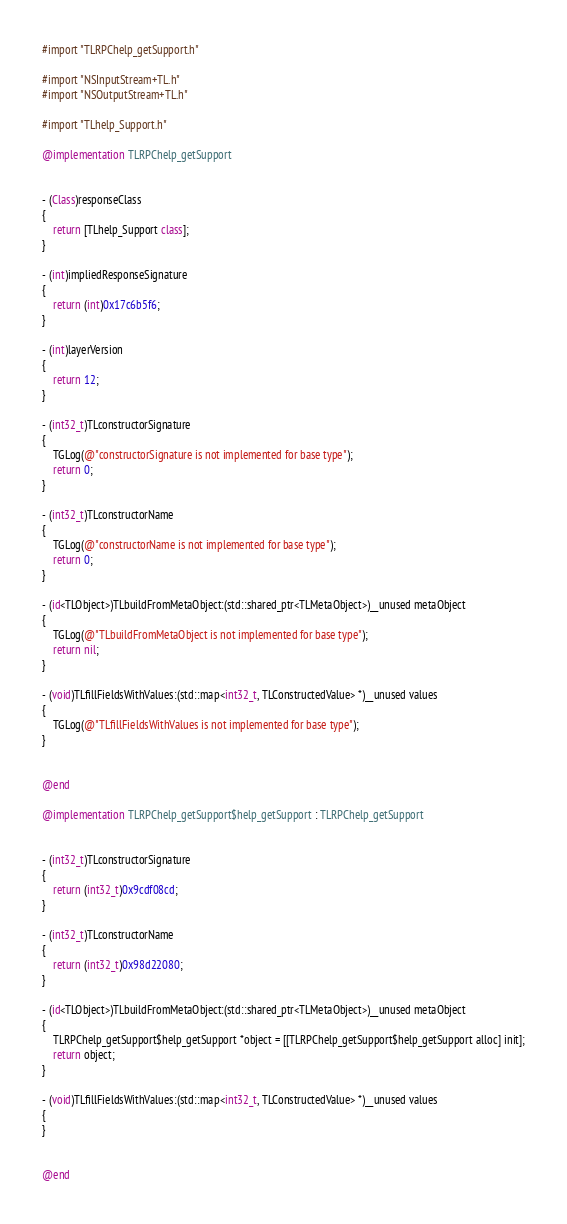<code> <loc_0><loc_0><loc_500><loc_500><_ObjectiveC_>#import "TLRPChelp_getSupport.h"

#import "NSInputStream+TL.h"
#import "NSOutputStream+TL.h"

#import "TLhelp_Support.h"

@implementation TLRPChelp_getSupport


- (Class)responseClass
{
    return [TLhelp_Support class];
}

- (int)impliedResponseSignature
{
    return (int)0x17c6b5f6;
}

- (int)layerVersion
{
    return 12;
}

- (int32_t)TLconstructorSignature
{
    TGLog(@"constructorSignature is not implemented for base type");
    return 0;
}

- (int32_t)TLconstructorName
{
    TGLog(@"constructorName is not implemented for base type");
    return 0;
}

- (id<TLObject>)TLbuildFromMetaObject:(std::shared_ptr<TLMetaObject>)__unused metaObject
{
    TGLog(@"TLbuildFromMetaObject is not implemented for base type");
    return nil;
}

- (void)TLfillFieldsWithValues:(std::map<int32_t, TLConstructedValue> *)__unused values
{
    TGLog(@"TLfillFieldsWithValues is not implemented for base type");
}


@end

@implementation TLRPChelp_getSupport$help_getSupport : TLRPChelp_getSupport


- (int32_t)TLconstructorSignature
{
    return (int32_t)0x9cdf08cd;
}

- (int32_t)TLconstructorName
{
    return (int32_t)0x98d22080;
}

- (id<TLObject>)TLbuildFromMetaObject:(std::shared_ptr<TLMetaObject>)__unused metaObject
{
    TLRPChelp_getSupport$help_getSupport *object = [[TLRPChelp_getSupport$help_getSupport alloc] init];
    return object;
}

- (void)TLfillFieldsWithValues:(std::map<int32_t, TLConstructedValue> *)__unused values
{
}


@end

</code> 